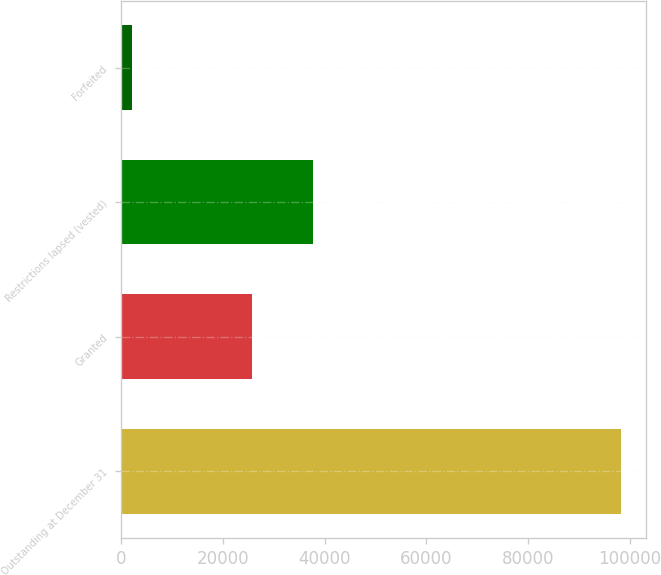Convert chart to OTSL. <chart><loc_0><loc_0><loc_500><loc_500><bar_chart><fcel>Outstanding at December 31<fcel>Granted<fcel>Restrictions lapsed (vested)<fcel>Forfeited<nl><fcel>98284<fcel>25662<fcel>37779<fcel>2170<nl></chart> 